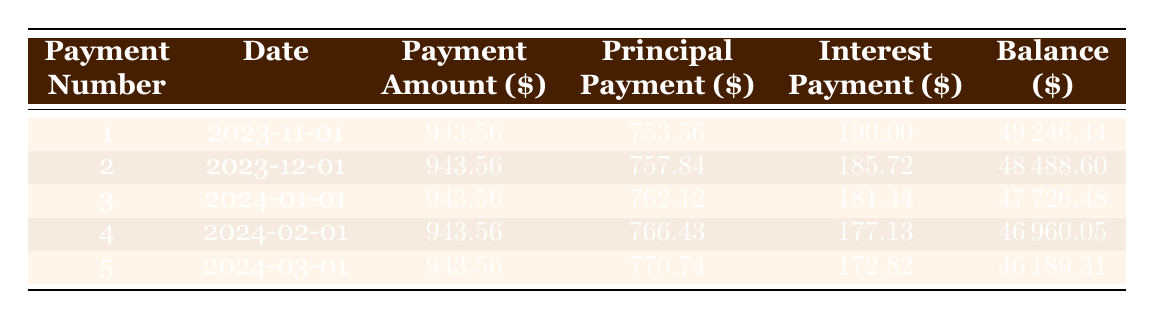What is the total loan amount for the Cultural Heritage Institute? The loan amount is provided directly in the data. It is stated to be 50,000.
Answer: 50,000 How much interest is paid in the first month? The table shows the interest payment for the first payment, which is 190.00.
Answer: 190.00 What is the remaining balance after the second payment? The remaining balance after the second payment is given in the table, listed as 48,488.60 after payment number 2.
Answer: 48,488.60 How much total principal is paid after the first five payments? To find the total principal paid, we sum the principal payments for all five payments: 753.56 + 757.84 + 762.12 + 766.43 + 770.74 = 3,010.69.
Answer: 3,010.69 Is the monthly payment amount the same for each payment? The payment amount is consistent for all payments listed in the table, each showing 943.56.
Answer: Yes What is the difference in total interest paid between the first and the last payment? The first interest payment is 190.00 and the last interest payment (after the fifth payment) is 172.82. The difference is 190.00 - 172.82 = 17.18.
Answer: 17.18 What is the average principal payment over the first five payments? To calculate the average principal payment, we sum the principal payments: 753.56 + 757.84 + 762.12 + 766.43 + 770.74 = 3,010.69. Dividing by 5 gives an average of 3,010.69 / 5 = 602.14.
Answer: 602.14 How much was the total payment amount over the loan term? The total payment amount is calculated by multiplying the payment amount by the total number of payments: 943.56 multiplied by 60 (5 years with monthly payments) equals 56,613.60.
Answer: 56,613.60 What is the remaining loan balance after the first payment? The table shows the remaining balance after the first payment as 49,246.44.
Answer: 49,246.44 